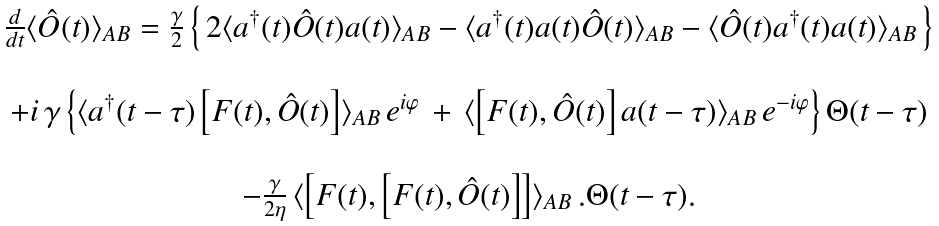Convert formula to latex. <formula><loc_0><loc_0><loc_500><loc_500>\begin{array} { c } \frac { d } { d t } \langle \hat { O } ( t ) \rangle _ { A B } = \frac { \gamma } { 2 } \left \{ \, 2 \langle a ^ { \dagger } ( t ) \hat { O } ( t ) a ( t ) \rangle _ { A B } - \langle a ^ { \dagger } ( t ) a ( t ) \hat { O } ( t ) \rangle _ { A B } - \langle \hat { O } ( t ) a ^ { \dagger } ( t ) a ( t ) \rangle _ { A B } \, \right \} \\ \\ + i \, \gamma \left \{ \langle a ^ { \dagger } ( t - \tau ) \left [ F ( t ) , \hat { O } ( t ) \right ] \rangle _ { A B } \, e ^ { i \varphi } \, + \, \langle \left [ F ( t ) , \hat { O } ( t ) \right ] a ( t - \tau ) \rangle _ { A B } \, e ^ { - i \varphi } \right \} \Theta ( t - \tau ) \\ \\ - \frac { \gamma } { 2 \eta } \, \langle \left [ F ( t ) , \left [ F ( t ) , \hat { O } ( t ) \right ] \right ] \rangle _ { A B } \, . \Theta ( t - \tau ) . \end{array}</formula> 